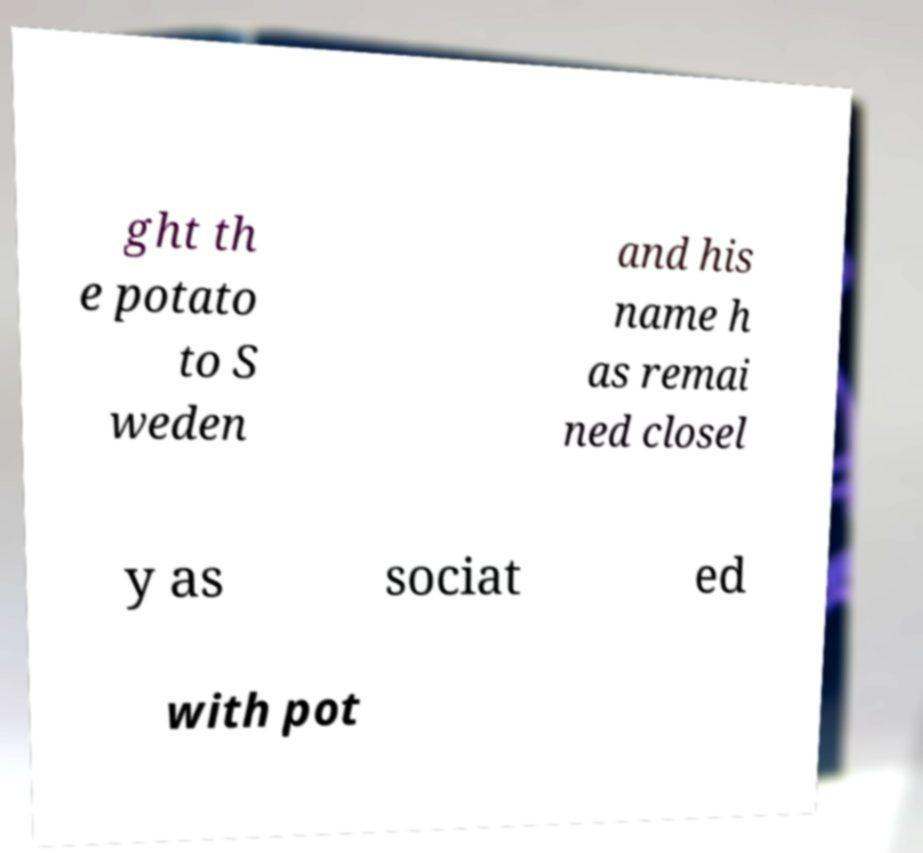Please read and relay the text visible in this image. What does it say? ght th e potato to S weden and his name h as remai ned closel y as sociat ed with pot 